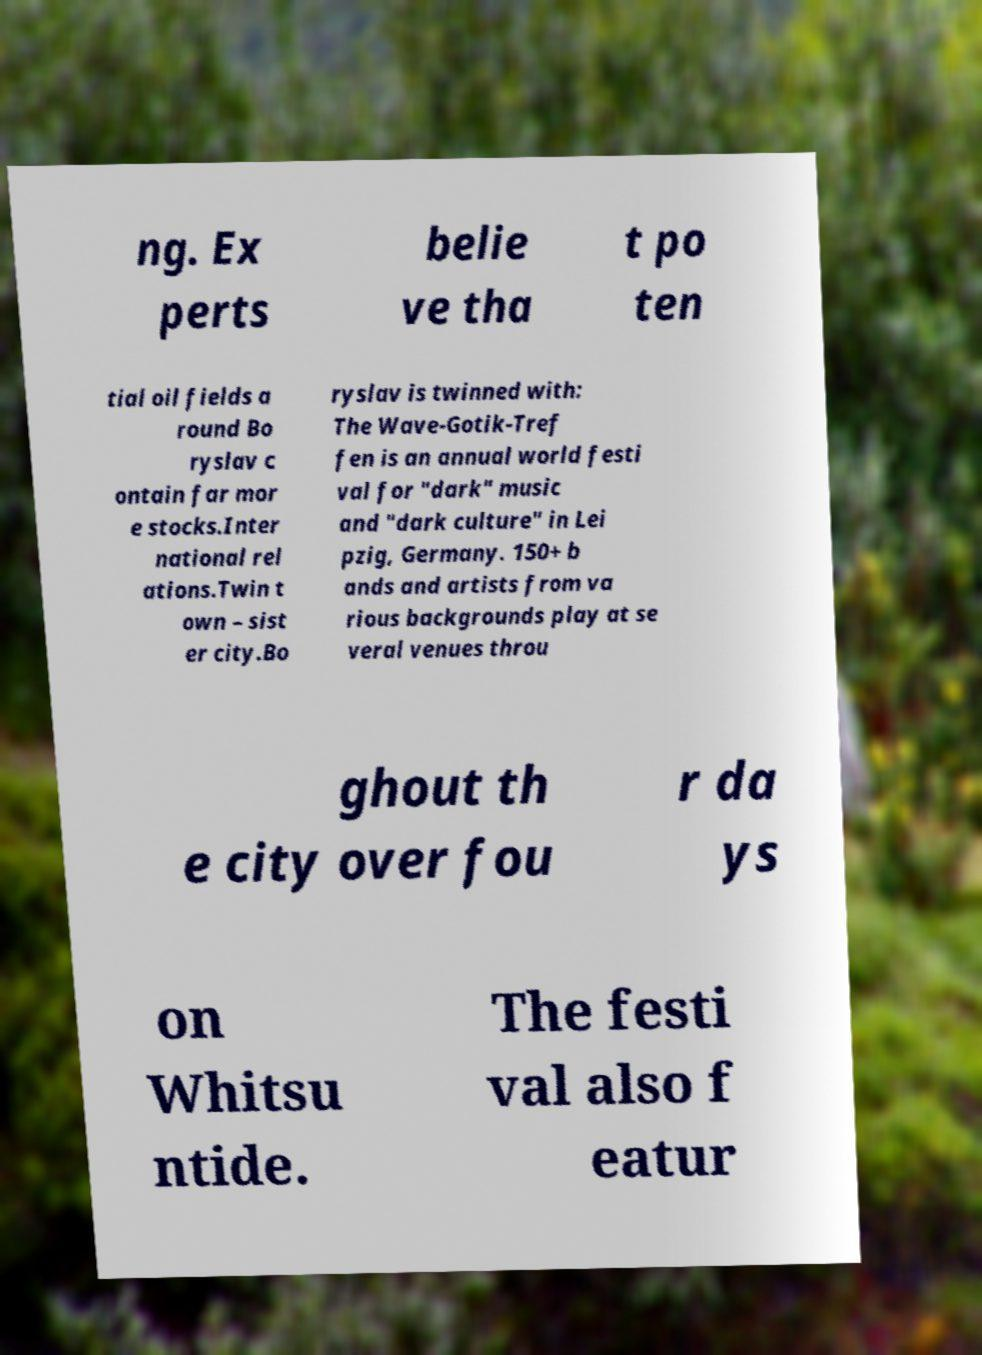Can you read and provide the text displayed in the image?This photo seems to have some interesting text. Can you extract and type it out for me? ng. Ex perts belie ve tha t po ten tial oil fields a round Bo ryslav c ontain far mor e stocks.Inter national rel ations.Twin t own – sist er city.Bo ryslav is twinned with: The Wave-Gotik-Tref fen is an annual world festi val for "dark" music and "dark culture" in Lei pzig, Germany. 150+ b ands and artists from va rious backgrounds play at se veral venues throu ghout th e city over fou r da ys on Whitsu ntide. The festi val also f eatur 